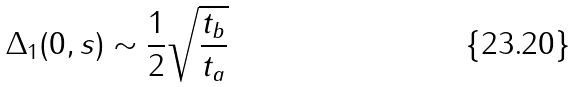<formula> <loc_0><loc_0><loc_500><loc_500>\Delta _ { 1 } ( 0 , s ) \sim \frac { 1 } { 2 } \sqrt { \frac { t _ { b } } { t _ { a } } }</formula> 